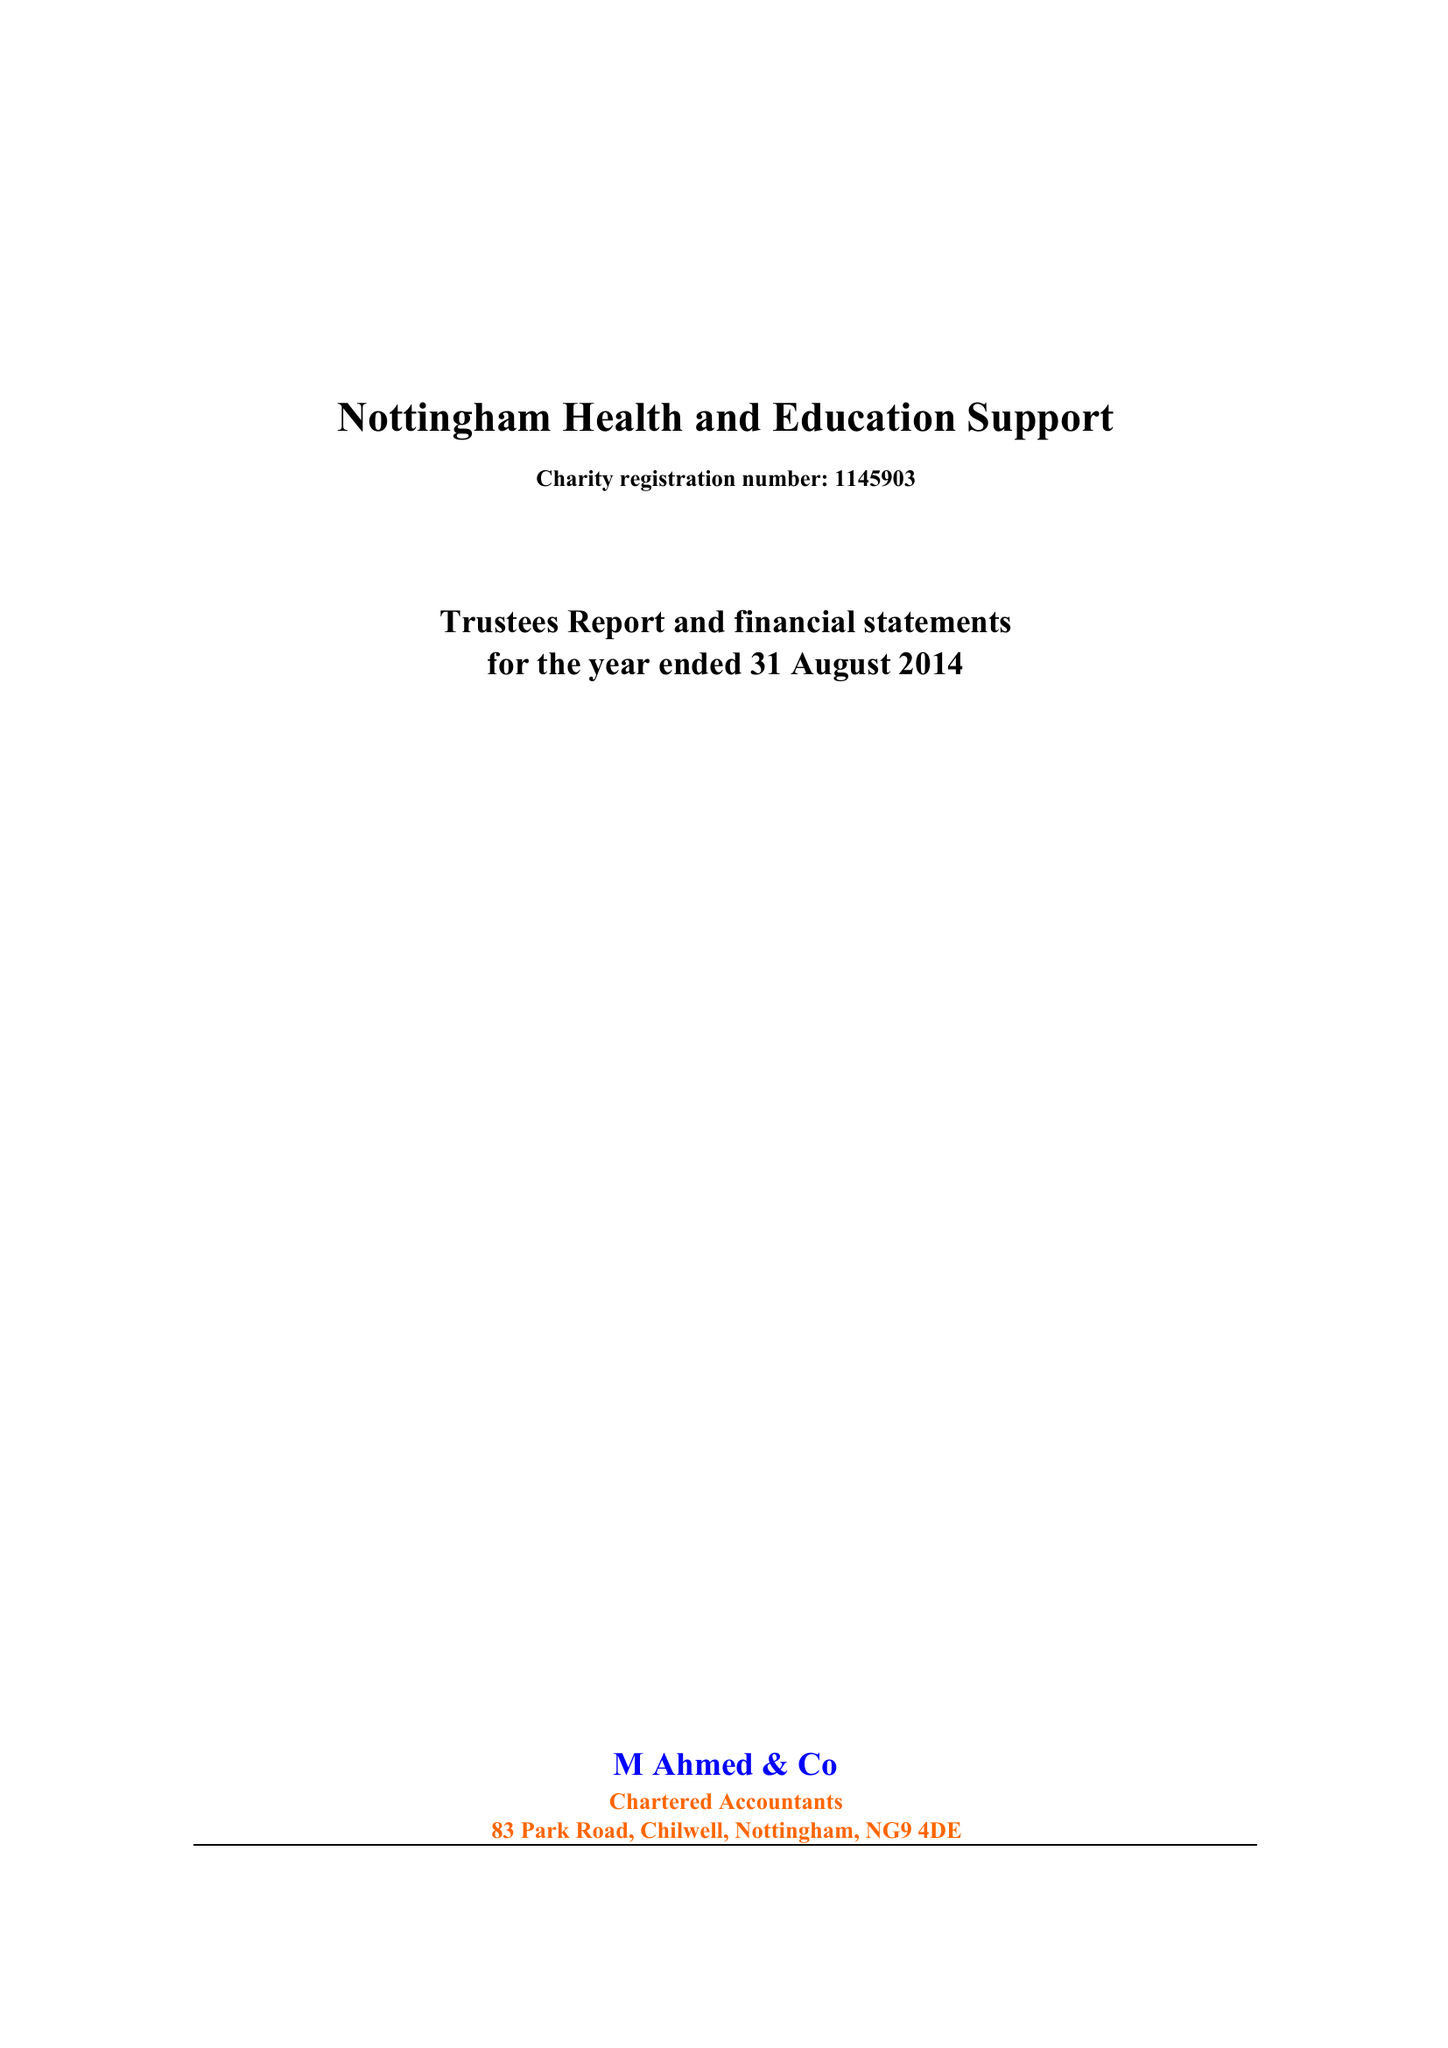What is the value for the charity_number?
Answer the question using a single word or phrase. 1145903 